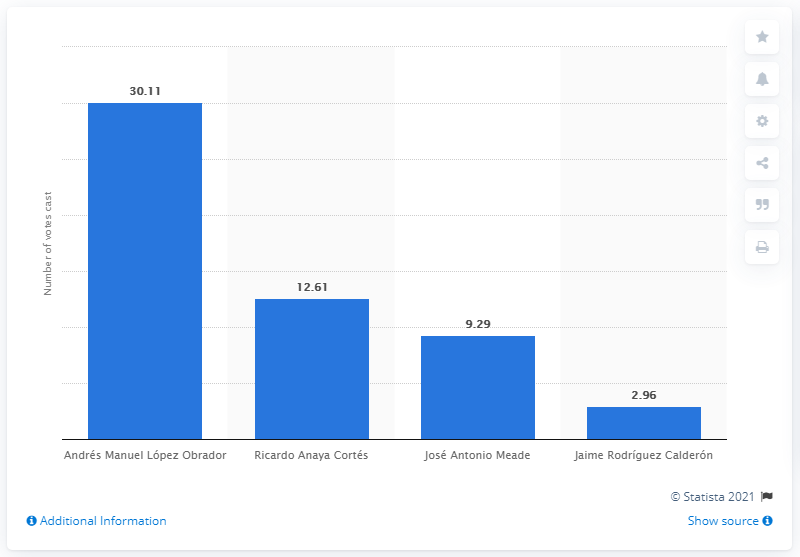What can this image tell us about the voter turnout in this election? The image presents the number of votes each candidate received but does not provide information on total voter turnout or the percentage of eligible voters who participated. To assess voter turnout, we would need additional data on the total number of eligible voters and how many actually voted. 